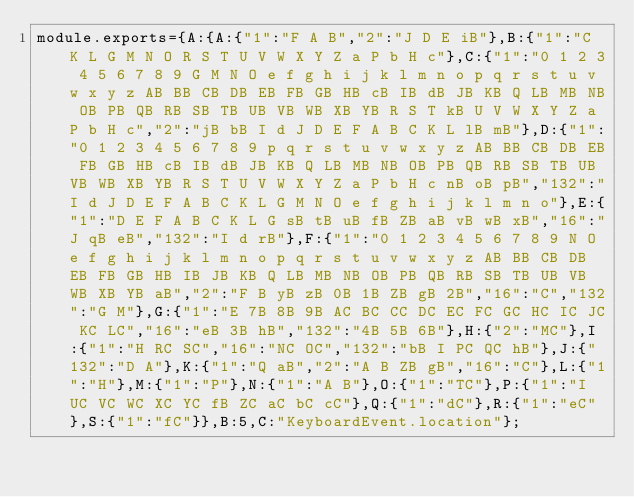Convert code to text. <code><loc_0><loc_0><loc_500><loc_500><_JavaScript_>module.exports={A:{A:{"1":"F A B","2":"J D E iB"},B:{"1":"C K L G M N O R S T U V W X Y Z a P b H c"},C:{"1":"0 1 2 3 4 5 6 7 8 9 G M N O e f g h i j k l m n o p q r s t u v w x y z AB BB CB DB EB FB GB HB cB IB dB JB KB Q LB MB NB OB PB QB RB SB TB UB VB WB XB YB R S T kB U V W X Y Z a P b H c","2":"jB bB I d J D E F A B C K L lB mB"},D:{"1":"0 1 2 3 4 5 6 7 8 9 p q r s t u v w x y z AB BB CB DB EB FB GB HB cB IB dB JB KB Q LB MB NB OB PB QB RB SB TB UB VB WB XB YB R S T U V W X Y Z a P b H c nB oB pB","132":"I d J D E F A B C K L G M N O e f g h i j k l m n o"},E:{"1":"D E F A B C K L G sB tB uB fB ZB aB vB wB xB","16":"J qB eB","132":"I d rB"},F:{"1":"0 1 2 3 4 5 6 7 8 9 N O e f g h i j k l m n o p q r s t u v w x y z AB BB CB DB EB FB GB HB IB JB KB Q LB MB NB OB PB QB RB SB TB UB VB WB XB YB aB","2":"F B yB zB 0B 1B ZB gB 2B","16":"C","132":"G M"},G:{"1":"E 7B 8B 9B AC BC CC DC EC FC GC HC IC JC KC LC","16":"eB 3B hB","132":"4B 5B 6B"},H:{"2":"MC"},I:{"1":"H RC SC","16":"NC OC","132":"bB I PC QC hB"},J:{"132":"D A"},K:{"1":"Q aB","2":"A B ZB gB","16":"C"},L:{"1":"H"},M:{"1":"P"},N:{"1":"A B"},O:{"1":"TC"},P:{"1":"I UC VC WC XC YC fB ZC aC bC cC"},Q:{"1":"dC"},R:{"1":"eC"},S:{"1":"fC"}},B:5,C:"KeyboardEvent.location"};
</code> 